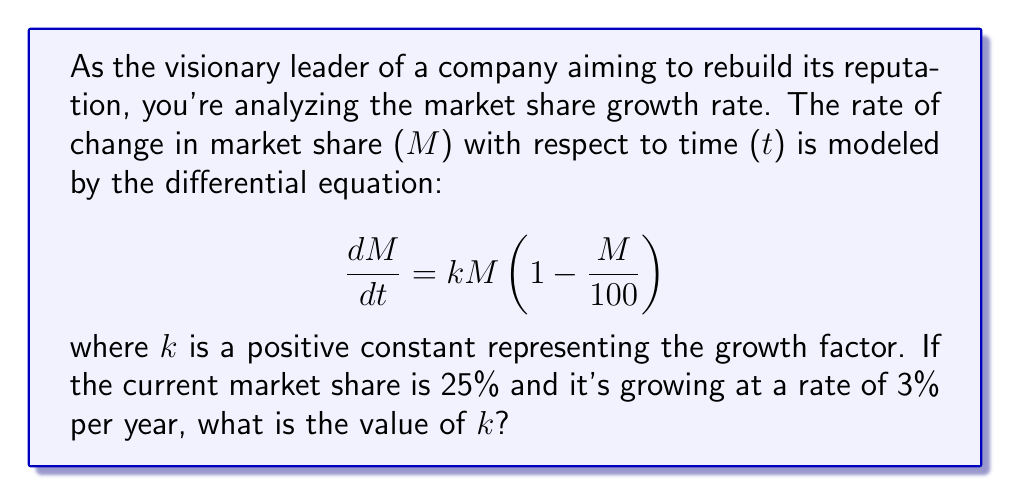Provide a solution to this math problem. To solve this problem, we'll follow these steps:

1) The given differential equation is a logistic growth model:
   $$\frac{dM}{dt} = kM(1-\frac{M}{100})$$

2) We're told that the current market share is 25%, so M = 25.

3) The growth rate is 3% per year, which means $\frac{dM}{dt} = 3$.

4) Let's substitute these values into the differential equation:

   $$3 = k(25)(1-\frac{25}{100})$$

5) Simplify the right side:
   $$3 = k(25)(0.75) = 18.75k$$

6) Now, we can solve for k:
   $$k = \frac{3}{18.75} = 0.16$$

Therefore, the growth factor k is 0.16.
Answer: k = 0.16 